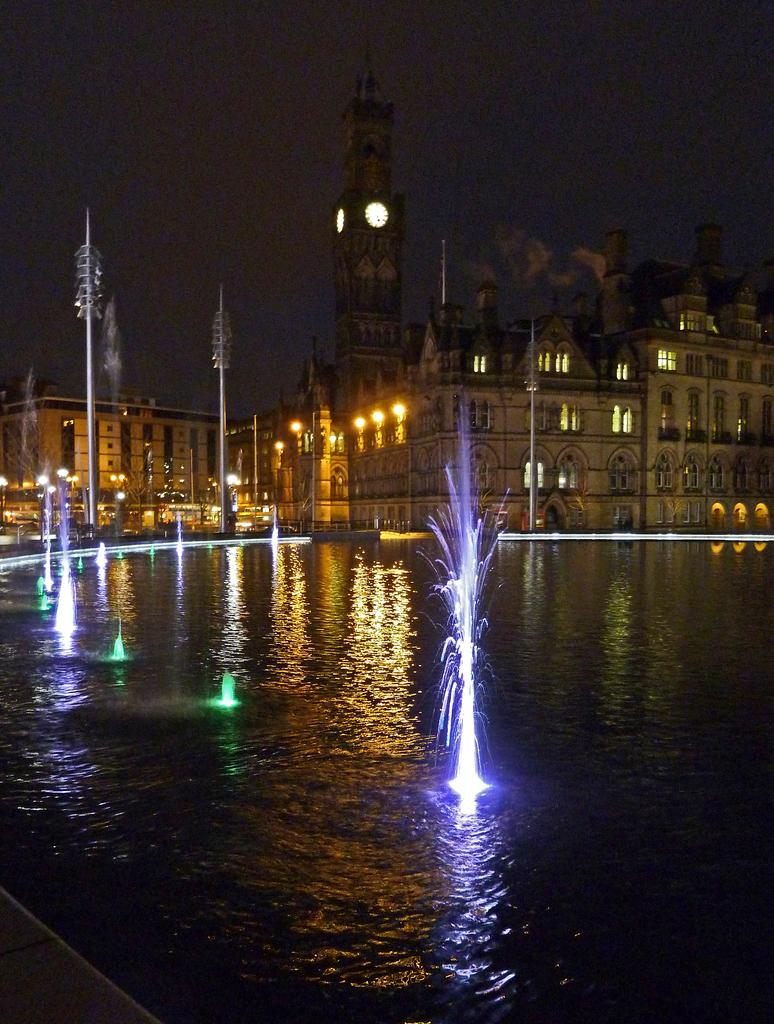What type of structures can be seen in the image? There are buildings, poles, and a clock tower in the image. What additional features are present in the image? There are lights, fountains, and water visible in the image. What is visible at the top of the image? The sky is visible at the top of the image. What is visible at the bottom of the image? Water is visible at the bottom of the image. What type of furniture is present in the image? There is no furniture present in the image. What emotion can be seen on the clock tower's face in the image? Clock towers do not have faces or emotions; they are inanimate objects. 